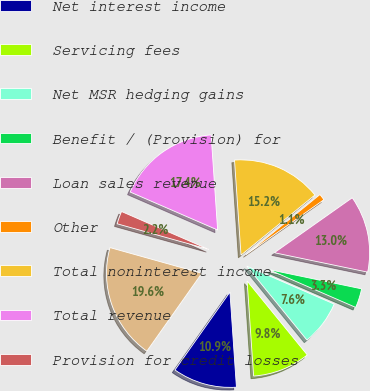Convert chart to OTSL. <chart><loc_0><loc_0><loc_500><loc_500><pie_chart><fcel>Year ended December 31 Dollars<fcel>Net interest income<fcel>Servicing fees<fcel>Net MSR hedging gains<fcel>Benefit / (Provision) for<fcel>Loan sales revenue<fcel>Other<fcel>Total noninterest income<fcel>Total revenue<fcel>Provision for credit losses<nl><fcel>19.56%<fcel>10.87%<fcel>9.78%<fcel>7.61%<fcel>3.26%<fcel>13.04%<fcel>1.09%<fcel>15.22%<fcel>17.39%<fcel>2.18%<nl></chart> 